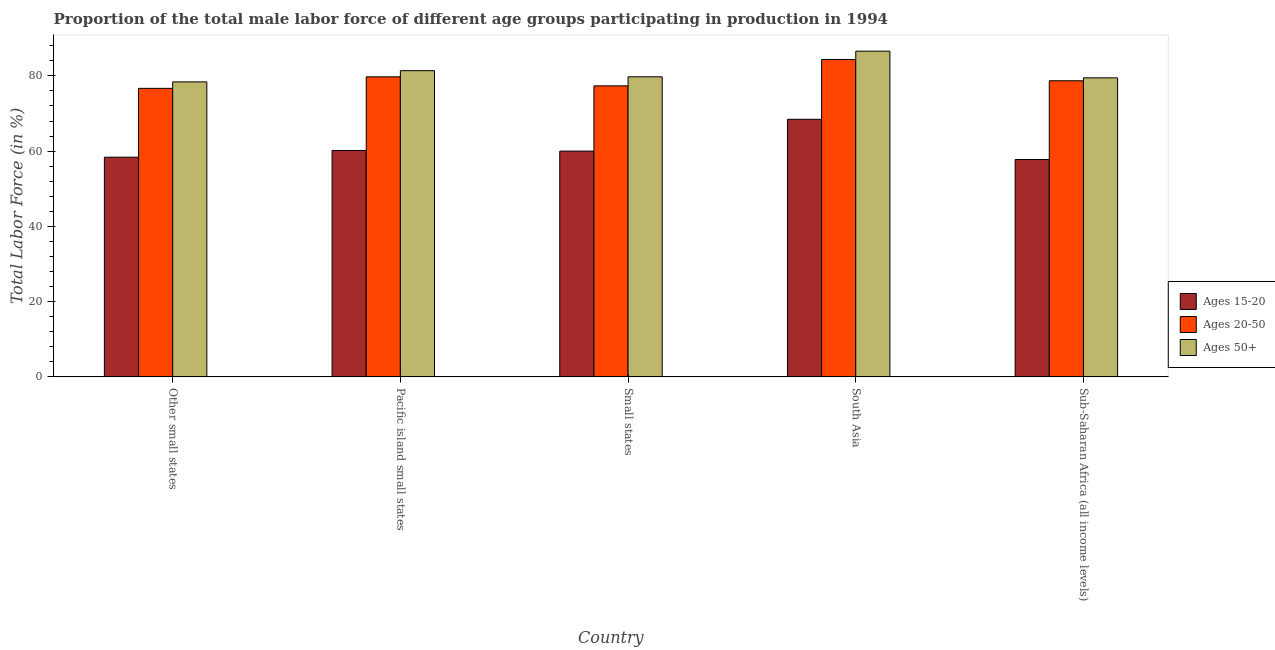How many different coloured bars are there?
Ensure brevity in your answer.  3. Are the number of bars per tick equal to the number of legend labels?
Your answer should be very brief. Yes. Are the number of bars on each tick of the X-axis equal?
Provide a short and direct response. Yes. How many bars are there on the 3rd tick from the left?
Ensure brevity in your answer.  3. How many bars are there on the 1st tick from the right?
Provide a short and direct response. 3. What is the label of the 1st group of bars from the left?
Your response must be concise. Other small states. In how many cases, is the number of bars for a given country not equal to the number of legend labels?
Ensure brevity in your answer.  0. What is the percentage of male labor force within the age group 15-20 in Small states?
Give a very brief answer. 60.01. Across all countries, what is the maximum percentage of male labor force within the age group 15-20?
Offer a terse response. 68.46. Across all countries, what is the minimum percentage of male labor force above age 50?
Make the answer very short. 78.41. In which country was the percentage of male labor force within the age group 20-50 minimum?
Provide a short and direct response. Other small states. What is the total percentage of male labor force within the age group 15-20 in the graph?
Give a very brief answer. 304.81. What is the difference between the percentage of male labor force within the age group 20-50 in Pacific island small states and that in Small states?
Keep it short and to the point. 2.4. What is the difference between the percentage of male labor force above age 50 in Sub-Saharan Africa (all income levels) and the percentage of male labor force within the age group 15-20 in Pacific island small states?
Offer a very short reply. 19.31. What is the average percentage of male labor force within the age group 20-50 per country?
Give a very brief answer. 79.37. What is the difference between the percentage of male labor force above age 50 and percentage of male labor force within the age group 20-50 in South Asia?
Make the answer very short. 2.21. In how many countries, is the percentage of male labor force within the age group 15-20 greater than 56 %?
Ensure brevity in your answer.  5. What is the ratio of the percentage of male labor force within the age group 15-20 in Pacific island small states to that in South Asia?
Offer a terse response. 0.88. Is the percentage of male labor force within the age group 15-20 in South Asia less than that in Sub-Saharan Africa (all income levels)?
Provide a succinct answer. No. Is the difference between the percentage of male labor force within the age group 15-20 in Other small states and Pacific island small states greater than the difference between the percentage of male labor force within the age group 20-50 in Other small states and Pacific island small states?
Offer a very short reply. Yes. What is the difference between the highest and the second highest percentage of male labor force within the age group 15-20?
Your response must be concise. 8.29. What is the difference between the highest and the lowest percentage of male labor force within the age group 15-20?
Provide a succinct answer. 10.69. In how many countries, is the percentage of male labor force within the age group 20-50 greater than the average percentage of male labor force within the age group 20-50 taken over all countries?
Offer a very short reply. 2. Is the sum of the percentage of male labor force above age 50 in Pacific island small states and Small states greater than the maximum percentage of male labor force within the age group 20-50 across all countries?
Offer a very short reply. Yes. What does the 2nd bar from the left in Pacific island small states represents?
Offer a very short reply. Ages 20-50. What does the 3rd bar from the right in South Asia represents?
Your answer should be very brief. Ages 15-20. Is it the case that in every country, the sum of the percentage of male labor force within the age group 15-20 and percentage of male labor force within the age group 20-50 is greater than the percentage of male labor force above age 50?
Give a very brief answer. Yes. How many bars are there?
Keep it short and to the point. 15. Are all the bars in the graph horizontal?
Make the answer very short. No. How many countries are there in the graph?
Keep it short and to the point. 5. What is the difference between two consecutive major ticks on the Y-axis?
Make the answer very short. 20. Are the values on the major ticks of Y-axis written in scientific E-notation?
Make the answer very short. No. Does the graph contain grids?
Offer a terse response. No. How many legend labels are there?
Provide a succinct answer. 3. What is the title of the graph?
Keep it short and to the point. Proportion of the total male labor force of different age groups participating in production in 1994. Does "Agricultural Nitrous Oxide" appear as one of the legend labels in the graph?
Your answer should be compact. No. What is the label or title of the X-axis?
Keep it short and to the point. Country. What is the Total Labor Force (in %) of Ages 15-20 in Other small states?
Offer a very short reply. 58.39. What is the Total Labor Force (in %) in Ages 20-50 in Other small states?
Make the answer very short. 76.69. What is the Total Labor Force (in %) in Ages 50+ in Other small states?
Offer a very short reply. 78.41. What is the Total Labor Force (in %) in Ages 15-20 in Pacific island small states?
Provide a succinct answer. 60.18. What is the Total Labor Force (in %) in Ages 20-50 in Pacific island small states?
Offer a very short reply. 79.75. What is the Total Labor Force (in %) of Ages 50+ in Pacific island small states?
Your answer should be very brief. 81.39. What is the Total Labor Force (in %) of Ages 15-20 in Small states?
Your response must be concise. 60.01. What is the Total Labor Force (in %) of Ages 20-50 in Small states?
Offer a terse response. 77.35. What is the Total Labor Force (in %) of Ages 50+ in Small states?
Your answer should be compact. 79.76. What is the Total Labor Force (in %) of Ages 15-20 in South Asia?
Keep it short and to the point. 68.46. What is the Total Labor Force (in %) in Ages 20-50 in South Asia?
Ensure brevity in your answer.  84.37. What is the Total Labor Force (in %) of Ages 50+ in South Asia?
Provide a short and direct response. 86.57. What is the Total Labor Force (in %) of Ages 15-20 in Sub-Saharan Africa (all income levels)?
Ensure brevity in your answer.  57.77. What is the Total Labor Force (in %) in Ages 20-50 in Sub-Saharan Africa (all income levels)?
Provide a short and direct response. 78.71. What is the Total Labor Force (in %) in Ages 50+ in Sub-Saharan Africa (all income levels)?
Your answer should be very brief. 79.49. Across all countries, what is the maximum Total Labor Force (in %) in Ages 15-20?
Keep it short and to the point. 68.46. Across all countries, what is the maximum Total Labor Force (in %) of Ages 20-50?
Your answer should be compact. 84.37. Across all countries, what is the maximum Total Labor Force (in %) of Ages 50+?
Offer a terse response. 86.57. Across all countries, what is the minimum Total Labor Force (in %) in Ages 15-20?
Provide a succinct answer. 57.77. Across all countries, what is the minimum Total Labor Force (in %) of Ages 20-50?
Your response must be concise. 76.69. Across all countries, what is the minimum Total Labor Force (in %) of Ages 50+?
Offer a terse response. 78.41. What is the total Total Labor Force (in %) of Ages 15-20 in the graph?
Your answer should be very brief. 304.81. What is the total Total Labor Force (in %) in Ages 20-50 in the graph?
Your answer should be compact. 396.87. What is the total Total Labor Force (in %) in Ages 50+ in the graph?
Offer a terse response. 405.62. What is the difference between the Total Labor Force (in %) in Ages 15-20 in Other small states and that in Pacific island small states?
Your answer should be compact. -1.79. What is the difference between the Total Labor Force (in %) in Ages 20-50 in Other small states and that in Pacific island small states?
Make the answer very short. -3.06. What is the difference between the Total Labor Force (in %) in Ages 50+ in Other small states and that in Pacific island small states?
Offer a very short reply. -2.98. What is the difference between the Total Labor Force (in %) of Ages 15-20 in Other small states and that in Small states?
Provide a succinct answer. -1.62. What is the difference between the Total Labor Force (in %) of Ages 20-50 in Other small states and that in Small states?
Your response must be concise. -0.66. What is the difference between the Total Labor Force (in %) of Ages 50+ in Other small states and that in Small states?
Offer a very short reply. -1.35. What is the difference between the Total Labor Force (in %) of Ages 15-20 in Other small states and that in South Asia?
Give a very brief answer. -10.07. What is the difference between the Total Labor Force (in %) of Ages 20-50 in Other small states and that in South Asia?
Give a very brief answer. -7.68. What is the difference between the Total Labor Force (in %) in Ages 50+ in Other small states and that in South Asia?
Offer a terse response. -8.17. What is the difference between the Total Labor Force (in %) of Ages 15-20 in Other small states and that in Sub-Saharan Africa (all income levels)?
Keep it short and to the point. 0.62. What is the difference between the Total Labor Force (in %) in Ages 20-50 in Other small states and that in Sub-Saharan Africa (all income levels)?
Offer a terse response. -2.02. What is the difference between the Total Labor Force (in %) of Ages 50+ in Other small states and that in Sub-Saharan Africa (all income levels)?
Offer a terse response. -1.08. What is the difference between the Total Labor Force (in %) in Ages 15-20 in Pacific island small states and that in Small states?
Give a very brief answer. 0.17. What is the difference between the Total Labor Force (in %) in Ages 20-50 in Pacific island small states and that in Small states?
Provide a short and direct response. 2.4. What is the difference between the Total Labor Force (in %) in Ages 50+ in Pacific island small states and that in Small states?
Provide a succinct answer. 1.63. What is the difference between the Total Labor Force (in %) of Ages 15-20 in Pacific island small states and that in South Asia?
Your response must be concise. -8.29. What is the difference between the Total Labor Force (in %) of Ages 20-50 in Pacific island small states and that in South Asia?
Offer a very short reply. -4.62. What is the difference between the Total Labor Force (in %) in Ages 50+ in Pacific island small states and that in South Asia?
Provide a short and direct response. -5.18. What is the difference between the Total Labor Force (in %) in Ages 15-20 in Pacific island small states and that in Sub-Saharan Africa (all income levels)?
Your answer should be very brief. 2.41. What is the difference between the Total Labor Force (in %) of Ages 20-50 in Pacific island small states and that in Sub-Saharan Africa (all income levels)?
Provide a succinct answer. 1.04. What is the difference between the Total Labor Force (in %) in Ages 50+ in Pacific island small states and that in Sub-Saharan Africa (all income levels)?
Offer a terse response. 1.91. What is the difference between the Total Labor Force (in %) of Ages 15-20 in Small states and that in South Asia?
Your answer should be compact. -8.45. What is the difference between the Total Labor Force (in %) in Ages 20-50 in Small states and that in South Asia?
Ensure brevity in your answer.  -7.02. What is the difference between the Total Labor Force (in %) of Ages 50+ in Small states and that in South Asia?
Your response must be concise. -6.82. What is the difference between the Total Labor Force (in %) of Ages 15-20 in Small states and that in Sub-Saharan Africa (all income levels)?
Ensure brevity in your answer.  2.24. What is the difference between the Total Labor Force (in %) of Ages 20-50 in Small states and that in Sub-Saharan Africa (all income levels)?
Provide a succinct answer. -1.35. What is the difference between the Total Labor Force (in %) of Ages 50+ in Small states and that in Sub-Saharan Africa (all income levels)?
Keep it short and to the point. 0.27. What is the difference between the Total Labor Force (in %) of Ages 15-20 in South Asia and that in Sub-Saharan Africa (all income levels)?
Give a very brief answer. 10.69. What is the difference between the Total Labor Force (in %) in Ages 20-50 in South Asia and that in Sub-Saharan Africa (all income levels)?
Your answer should be compact. 5.66. What is the difference between the Total Labor Force (in %) in Ages 50+ in South Asia and that in Sub-Saharan Africa (all income levels)?
Offer a very short reply. 7.09. What is the difference between the Total Labor Force (in %) of Ages 15-20 in Other small states and the Total Labor Force (in %) of Ages 20-50 in Pacific island small states?
Offer a very short reply. -21.36. What is the difference between the Total Labor Force (in %) of Ages 15-20 in Other small states and the Total Labor Force (in %) of Ages 50+ in Pacific island small states?
Your response must be concise. -23. What is the difference between the Total Labor Force (in %) of Ages 20-50 in Other small states and the Total Labor Force (in %) of Ages 50+ in Pacific island small states?
Offer a very short reply. -4.7. What is the difference between the Total Labor Force (in %) of Ages 15-20 in Other small states and the Total Labor Force (in %) of Ages 20-50 in Small states?
Give a very brief answer. -18.96. What is the difference between the Total Labor Force (in %) of Ages 15-20 in Other small states and the Total Labor Force (in %) of Ages 50+ in Small states?
Provide a short and direct response. -21.37. What is the difference between the Total Labor Force (in %) in Ages 20-50 in Other small states and the Total Labor Force (in %) in Ages 50+ in Small states?
Your answer should be compact. -3.07. What is the difference between the Total Labor Force (in %) of Ages 15-20 in Other small states and the Total Labor Force (in %) of Ages 20-50 in South Asia?
Ensure brevity in your answer.  -25.98. What is the difference between the Total Labor Force (in %) in Ages 15-20 in Other small states and the Total Labor Force (in %) in Ages 50+ in South Asia?
Ensure brevity in your answer.  -28.18. What is the difference between the Total Labor Force (in %) in Ages 20-50 in Other small states and the Total Labor Force (in %) in Ages 50+ in South Asia?
Provide a succinct answer. -9.88. What is the difference between the Total Labor Force (in %) of Ages 15-20 in Other small states and the Total Labor Force (in %) of Ages 20-50 in Sub-Saharan Africa (all income levels)?
Offer a terse response. -20.32. What is the difference between the Total Labor Force (in %) of Ages 15-20 in Other small states and the Total Labor Force (in %) of Ages 50+ in Sub-Saharan Africa (all income levels)?
Your answer should be very brief. -21.1. What is the difference between the Total Labor Force (in %) of Ages 20-50 in Other small states and the Total Labor Force (in %) of Ages 50+ in Sub-Saharan Africa (all income levels)?
Offer a very short reply. -2.79. What is the difference between the Total Labor Force (in %) in Ages 15-20 in Pacific island small states and the Total Labor Force (in %) in Ages 20-50 in Small states?
Keep it short and to the point. -17.18. What is the difference between the Total Labor Force (in %) in Ages 15-20 in Pacific island small states and the Total Labor Force (in %) in Ages 50+ in Small states?
Keep it short and to the point. -19.58. What is the difference between the Total Labor Force (in %) of Ages 20-50 in Pacific island small states and the Total Labor Force (in %) of Ages 50+ in Small states?
Your response must be concise. -0.01. What is the difference between the Total Labor Force (in %) in Ages 15-20 in Pacific island small states and the Total Labor Force (in %) in Ages 20-50 in South Asia?
Make the answer very short. -24.19. What is the difference between the Total Labor Force (in %) of Ages 15-20 in Pacific island small states and the Total Labor Force (in %) of Ages 50+ in South Asia?
Your answer should be very brief. -26.4. What is the difference between the Total Labor Force (in %) in Ages 20-50 in Pacific island small states and the Total Labor Force (in %) in Ages 50+ in South Asia?
Your answer should be very brief. -6.82. What is the difference between the Total Labor Force (in %) of Ages 15-20 in Pacific island small states and the Total Labor Force (in %) of Ages 20-50 in Sub-Saharan Africa (all income levels)?
Your answer should be very brief. -18.53. What is the difference between the Total Labor Force (in %) of Ages 15-20 in Pacific island small states and the Total Labor Force (in %) of Ages 50+ in Sub-Saharan Africa (all income levels)?
Your response must be concise. -19.31. What is the difference between the Total Labor Force (in %) in Ages 20-50 in Pacific island small states and the Total Labor Force (in %) in Ages 50+ in Sub-Saharan Africa (all income levels)?
Your answer should be very brief. 0.26. What is the difference between the Total Labor Force (in %) of Ages 15-20 in Small states and the Total Labor Force (in %) of Ages 20-50 in South Asia?
Your answer should be compact. -24.36. What is the difference between the Total Labor Force (in %) of Ages 15-20 in Small states and the Total Labor Force (in %) of Ages 50+ in South Asia?
Keep it short and to the point. -26.57. What is the difference between the Total Labor Force (in %) in Ages 20-50 in Small states and the Total Labor Force (in %) in Ages 50+ in South Asia?
Your answer should be compact. -9.22. What is the difference between the Total Labor Force (in %) of Ages 15-20 in Small states and the Total Labor Force (in %) of Ages 20-50 in Sub-Saharan Africa (all income levels)?
Make the answer very short. -18.7. What is the difference between the Total Labor Force (in %) of Ages 15-20 in Small states and the Total Labor Force (in %) of Ages 50+ in Sub-Saharan Africa (all income levels)?
Offer a terse response. -19.48. What is the difference between the Total Labor Force (in %) of Ages 20-50 in Small states and the Total Labor Force (in %) of Ages 50+ in Sub-Saharan Africa (all income levels)?
Your answer should be very brief. -2.13. What is the difference between the Total Labor Force (in %) in Ages 15-20 in South Asia and the Total Labor Force (in %) in Ages 20-50 in Sub-Saharan Africa (all income levels)?
Offer a terse response. -10.24. What is the difference between the Total Labor Force (in %) in Ages 15-20 in South Asia and the Total Labor Force (in %) in Ages 50+ in Sub-Saharan Africa (all income levels)?
Offer a very short reply. -11.02. What is the difference between the Total Labor Force (in %) in Ages 20-50 in South Asia and the Total Labor Force (in %) in Ages 50+ in Sub-Saharan Africa (all income levels)?
Your answer should be compact. 4.88. What is the average Total Labor Force (in %) in Ages 15-20 per country?
Offer a terse response. 60.96. What is the average Total Labor Force (in %) in Ages 20-50 per country?
Offer a very short reply. 79.37. What is the average Total Labor Force (in %) of Ages 50+ per country?
Keep it short and to the point. 81.12. What is the difference between the Total Labor Force (in %) in Ages 15-20 and Total Labor Force (in %) in Ages 20-50 in Other small states?
Ensure brevity in your answer.  -18.3. What is the difference between the Total Labor Force (in %) in Ages 15-20 and Total Labor Force (in %) in Ages 50+ in Other small states?
Provide a short and direct response. -20.02. What is the difference between the Total Labor Force (in %) in Ages 20-50 and Total Labor Force (in %) in Ages 50+ in Other small states?
Offer a terse response. -1.72. What is the difference between the Total Labor Force (in %) in Ages 15-20 and Total Labor Force (in %) in Ages 20-50 in Pacific island small states?
Your answer should be very brief. -19.57. What is the difference between the Total Labor Force (in %) in Ages 15-20 and Total Labor Force (in %) in Ages 50+ in Pacific island small states?
Offer a terse response. -21.22. What is the difference between the Total Labor Force (in %) in Ages 20-50 and Total Labor Force (in %) in Ages 50+ in Pacific island small states?
Provide a succinct answer. -1.64. What is the difference between the Total Labor Force (in %) of Ages 15-20 and Total Labor Force (in %) of Ages 20-50 in Small states?
Your answer should be very brief. -17.34. What is the difference between the Total Labor Force (in %) in Ages 15-20 and Total Labor Force (in %) in Ages 50+ in Small states?
Offer a very short reply. -19.75. What is the difference between the Total Labor Force (in %) in Ages 20-50 and Total Labor Force (in %) in Ages 50+ in Small states?
Your answer should be compact. -2.41. What is the difference between the Total Labor Force (in %) in Ages 15-20 and Total Labor Force (in %) in Ages 20-50 in South Asia?
Offer a very short reply. -15.91. What is the difference between the Total Labor Force (in %) in Ages 15-20 and Total Labor Force (in %) in Ages 50+ in South Asia?
Your response must be concise. -18.11. What is the difference between the Total Labor Force (in %) of Ages 20-50 and Total Labor Force (in %) of Ages 50+ in South Asia?
Your answer should be very brief. -2.21. What is the difference between the Total Labor Force (in %) of Ages 15-20 and Total Labor Force (in %) of Ages 20-50 in Sub-Saharan Africa (all income levels)?
Offer a terse response. -20.94. What is the difference between the Total Labor Force (in %) in Ages 15-20 and Total Labor Force (in %) in Ages 50+ in Sub-Saharan Africa (all income levels)?
Your answer should be very brief. -21.72. What is the difference between the Total Labor Force (in %) in Ages 20-50 and Total Labor Force (in %) in Ages 50+ in Sub-Saharan Africa (all income levels)?
Provide a succinct answer. -0.78. What is the ratio of the Total Labor Force (in %) in Ages 15-20 in Other small states to that in Pacific island small states?
Your answer should be compact. 0.97. What is the ratio of the Total Labor Force (in %) in Ages 20-50 in Other small states to that in Pacific island small states?
Give a very brief answer. 0.96. What is the ratio of the Total Labor Force (in %) in Ages 50+ in Other small states to that in Pacific island small states?
Offer a very short reply. 0.96. What is the ratio of the Total Labor Force (in %) in Ages 15-20 in Other small states to that in Small states?
Make the answer very short. 0.97. What is the ratio of the Total Labor Force (in %) of Ages 50+ in Other small states to that in Small states?
Provide a short and direct response. 0.98. What is the ratio of the Total Labor Force (in %) of Ages 15-20 in Other small states to that in South Asia?
Give a very brief answer. 0.85. What is the ratio of the Total Labor Force (in %) of Ages 20-50 in Other small states to that in South Asia?
Make the answer very short. 0.91. What is the ratio of the Total Labor Force (in %) of Ages 50+ in Other small states to that in South Asia?
Provide a short and direct response. 0.91. What is the ratio of the Total Labor Force (in %) of Ages 15-20 in Other small states to that in Sub-Saharan Africa (all income levels)?
Keep it short and to the point. 1.01. What is the ratio of the Total Labor Force (in %) in Ages 20-50 in Other small states to that in Sub-Saharan Africa (all income levels)?
Provide a succinct answer. 0.97. What is the ratio of the Total Labor Force (in %) of Ages 50+ in Other small states to that in Sub-Saharan Africa (all income levels)?
Provide a succinct answer. 0.99. What is the ratio of the Total Labor Force (in %) of Ages 15-20 in Pacific island small states to that in Small states?
Offer a very short reply. 1. What is the ratio of the Total Labor Force (in %) of Ages 20-50 in Pacific island small states to that in Small states?
Offer a very short reply. 1.03. What is the ratio of the Total Labor Force (in %) in Ages 50+ in Pacific island small states to that in Small states?
Provide a short and direct response. 1.02. What is the ratio of the Total Labor Force (in %) in Ages 15-20 in Pacific island small states to that in South Asia?
Your answer should be compact. 0.88. What is the ratio of the Total Labor Force (in %) in Ages 20-50 in Pacific island small states to that in South Asia?
Ensure brevity in your answer.  0.95. What is the ratio of the Total Labor Force (in %) in Ages 50+ in Pacific island small states to that in South Asia?
Offer a terse response. 0.94. What is the ratio of the Total Labor Force (in %) of Ages 15-20 in Pacific island small states to that in Sub-Saharan Africa (all income levels)?
Your answer should be compact. 1.04. What is the ratio of the Total Labor Force (in %) in Ages 20-50 in Pacific island small states to that in Sub-Saharan Africa (all income levels)?
Give a very brief answer. 1.01. What is the ratio of the Total Labor Force (in %) in Ages 50+ in Pacific island small states to that in Sub-Saharan Africa (all income levels)?
Your answer should be compact. 1.02. What is the ratio of the Total Labor Force (in %) in Ages 15-20 in Small states to that in South Asia?
Your response must be concise. 0.88. What is the ratio of the Total Labor Force (in %) in Ages 20-50 in Small states to that in South Asia?
Offer a very short reply. 0.92. What is the ratio of the Total Labor Force (in %) in Ages 50+ in Small states to that in South Asia?
Offer a terse response. 0.92. What is the ratio of the Total Labor Force (in %) of Ages 15-20 in Small states to that in Sub-Saharan Africa (all income levels)?
Your response must be concise. 1.04. What is the ratio of the Total Labor Force (in %) in Ages 20-50 in Small states to that in Sub-Saharan Africa (all income levels)?
Make the answer very short. 0.98. What is the ratio of the Total Labor Force (in %) in Ages 15-20 in South Asia to that in Sub-Saharan Africa (all income levels)?
Your response must be concise. 1.19. What is the ratio of the Total Labor Force (in %) in Ages 20-50 in South Asia to that in Sub-Saharan Africa (all income levels)?
Make the answer very short. 1.07. What is the ratio of the Total Labor Force (in %) of Ages 50+ in South Asia to that in Sub-Saharan Africa (all income levels)?
Offer a terse response. 1.09. What is the difference between the highest and the second highest Total Labor Force (in %) of Ages 15-20?
Ensure brevity in your answer.  8.29. What is the difference between the highest and the second highest Total Labor Force (in %) of Ages 20-50?
Offer a very short reply. 4.62. What is the difference between the highest and the second highest Total Labor Force (in %) in Ages 50+?
Ensure brevity in your answer.  5.18. What is the difference between the highest and the lowest Total Labor Force (in %) in Ages 15-20?
Your response must be concise. 10.69. What is the difference between the highest and the lowest Total Labor Force (in %) of Ages 20-50?
Offer a very short reply. 7.68. What is the difference between the highest and the lowest Total Labor Force (in %) in Ages 50+?
Your response must be concise. 8.17. 